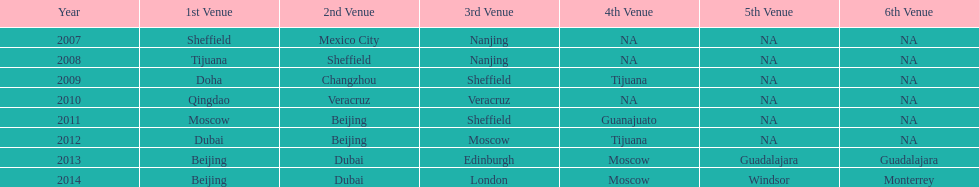During which years was the greatest quantity of venues recorded? 2013, 2014. 